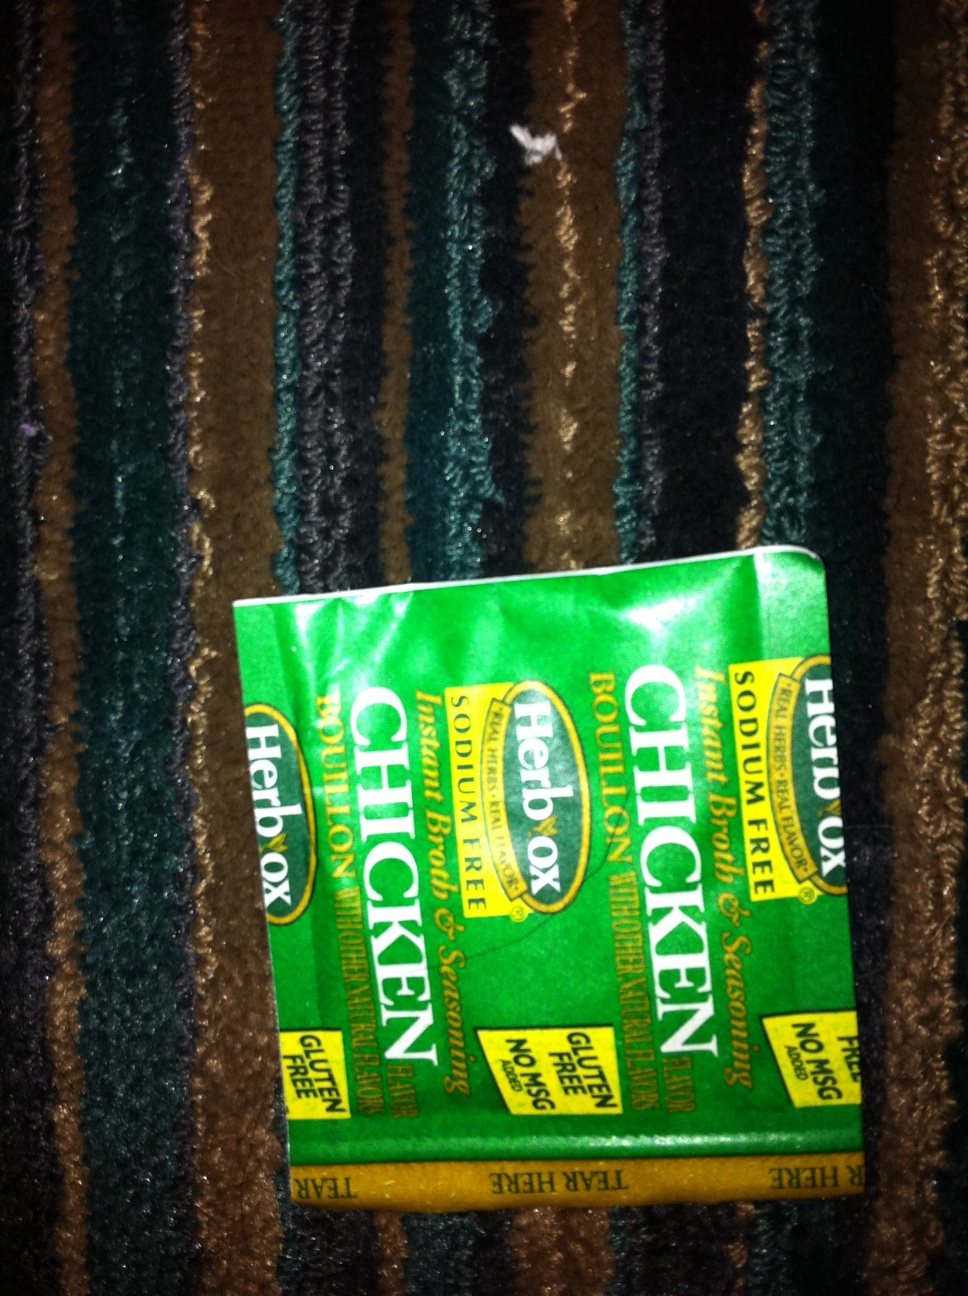If this bouillon could talk, what would its favorite recipe be? If Herbox Chicken Bouillon could talk, it would proudly boast about its favorite recipe, ‘Grandma’s Comforting Chicken Noodle Soup.’ With a nostalgic tone, it would say:

‘Start with a large pot, fill it with two quarts of water, and bring it to a boil. Dissolve four of my packets in the water, ensuring the rich, savory flavor infuses every drop. Add two diced carrots, two stalks of chopped celery, and one diced onion. Let them simmer until tender. Now, toss in shredded chicken from a rotisserie bird and a couple of handfuls of egg noodles. Cook until the noodles are just right. My secret ingredient will bring out the best in each component.

As you ladle the steaming soup into bowls, don’t forget a sprinkle of fresh parsley. One sip will take you back to the days when grandma’s kitchen was filled with love and warmth. Enjoy, for this is my favorite masterpiece!' 